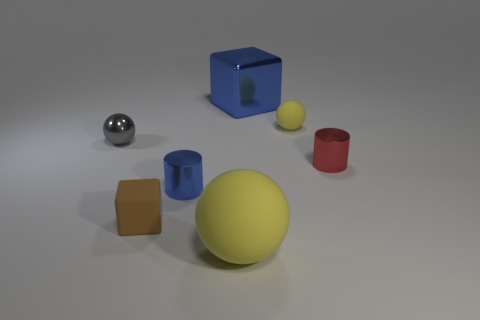What number of other objects are the same shape as the small yellow object? 2 